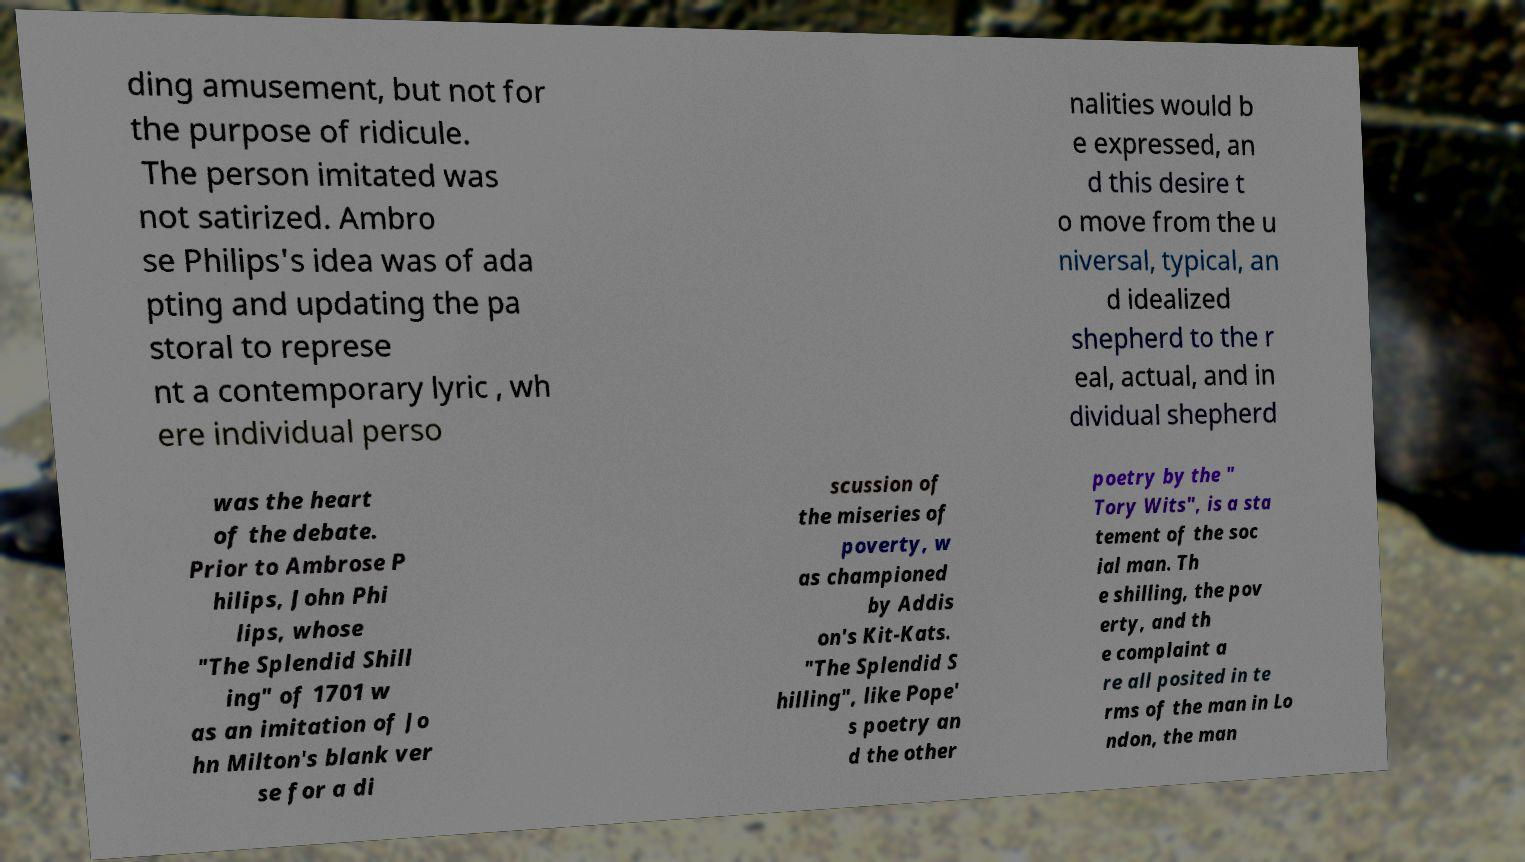For documentation purposes, I need the text within this image transcribed. Could you provide that? ding amusement, but not for the purpose of ridicule. The person imitated was not satirized. Ambro se Philips's idea was of ada pting and updating the pa storal to represe nt a contemporary lyric , wh ere individual perso nalities would b e expressed, an d this desire t o move from the u niversal, typical, an d idealized shepherd to the r eal, actual, and in dividual shepherd was the heart of the debate. Prior to Ambrose P hilips, John Phi lips, whose "The Splendid Shill ing" of 1701 w as an imitation of Jo hn Milton's blank ver se for a di scussion of the miseries of poverty, w as championed by Addis on's Kit-Kats. "The Splendid S hilling", like Pope' s poetry an d the other poetry by the " Tory Wits", is a sta tement of the soc ial man. Th e shilling, the pov erty, and th e complaint a re all posited in te rms of the man in Lo ndon, the man 